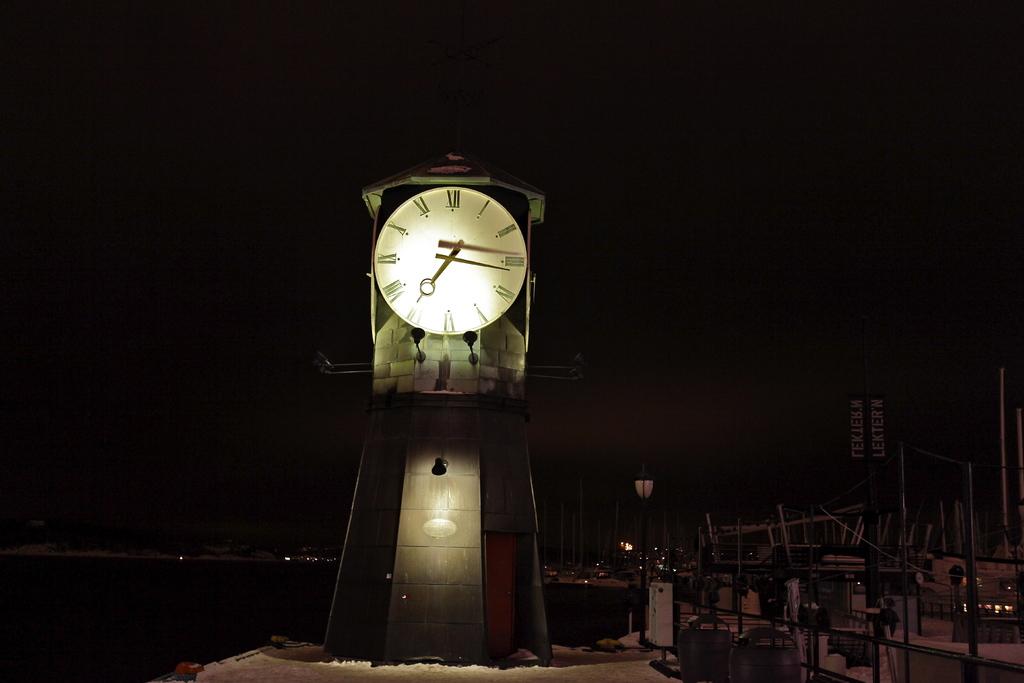What time does the clock show?
Keep it short and to the point. 7:15. 